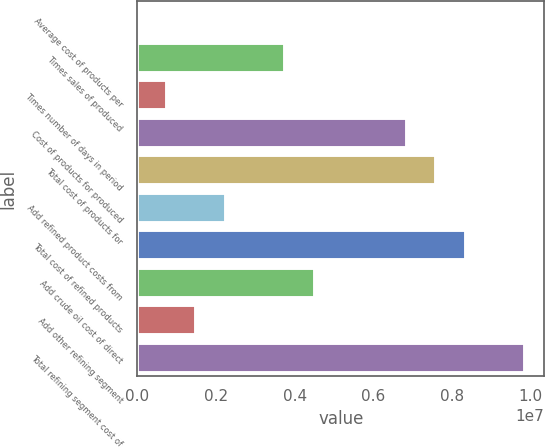Convert chart to OTSL. <chart><loc_0><loc_0><loc_500><loc_500><bar_chart><fcel>Average cost of products per<fcel>Times sales of produced<fcel>Times number of days in period<fcel>Cost of products for produced<fcel>Total cost of products for<fcel>Add refined product costs from<fcel>Total cost of refined products<fcel>Add crude oil cost of direct<fcel>Add other refining segment<fcel>Total refining segment cost of<nl><fcel>82.27<fcel>3.75522e+06<fcel>751110<fcel>6.85071e+06<fcel>7.60174e+06<fcel>2.25316e+06<fcel>8.35277e+06<fcel>4.50625e+06<fcel>1.50214e+06<fcel>9.85482e+06<nl></chart> 